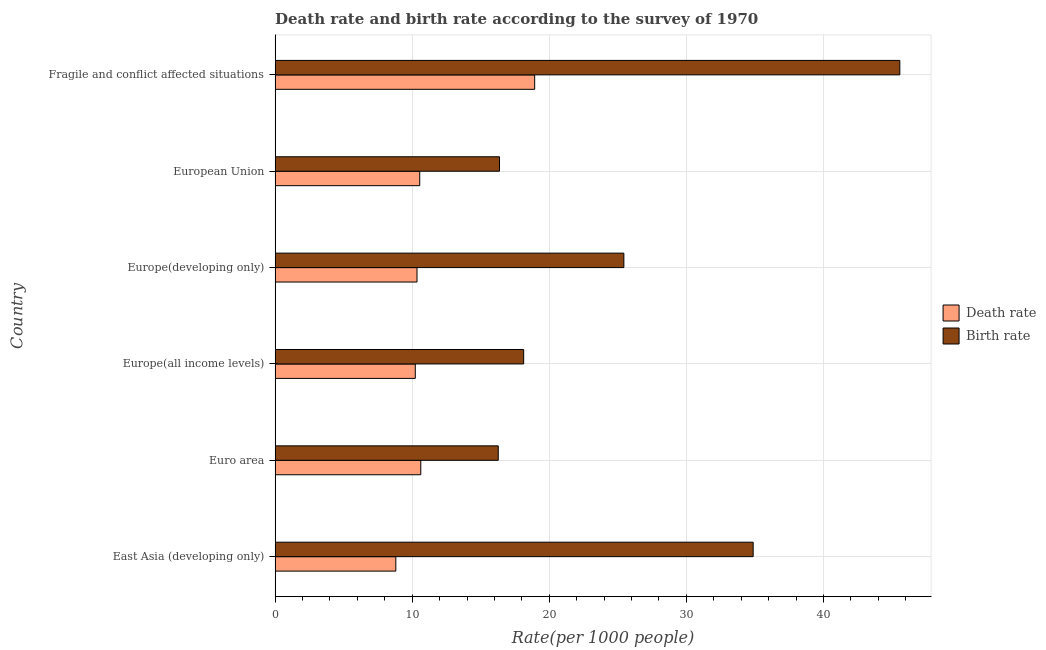How many different coloured bars are there?
Provide a short and direct response. 2. How many groups of bars are there?
Make the answer very short. 6. Are the number of bars per tick equal to the number of legend labels?
Your answer should be very brief. Yes. How many bars are there on the 5th tick from the top?
Keep it short and to the point. 2. How many bars are there on the 2nd tick from the bottom?
Your answer should be compact. 2. What is the label of the 6th group of bars from the top?
Give a very brief answer. East Asia (developing only). What is the death rate in Fragile and conflict affected situations?
Keep it short and to the point. 18.93. Across all countries, what is the maximum death rate?
Make the answer very short. 18.93. Across all countries, what is the minimum death rate?
Your answer should be very brief. 8.81. In which country was the death rate maximum?
Ensure brevity in your answer.  Fragile and conflict affected situations. In which country was the death rate minimum?
Your answer should be very brief. East Asia (developing only). What is the total death rate in the graph?
Your answer should be compact. 69.5. What is the difference between the birth rate in East Asia (developing only) and that in Fragile and conflict affected situations?
Offer a very short reply. -10.7. What is the difference between the death rate in Euro area and the birth rate in Fragile and conflict affected situations?
Keep it short and to the point. -34.94. What is the average birth rate per country?
Give a very brief answer. 26.11. What is the difference between the birth rate and death rate in European Union?
Offer a terse response. 5.82. In how many countries, is the birth rate greater than 2 ?
Offer a terse response. 6. What is the ratio of the death rate in Euro area to that in Fragile and conflict affected situations?
Make the answer very short. 0.56. What is the difference between the highest and the second highest death rate?
Keep it short and to the point. 8.31. What is the difference between the highest and the lowest death rate?
Ensure brevity in your answer.  10.13. What does the 1st bar from the top in Euro area represents?
Your response must be concise. Birth rate. What does the 2nd bar from the bottom in European Union represents?
Give a very brief answer. Birth rate. How many bars are there?
Your response must be concise. 12. Are all the bars in the graph horizontal?
Provide a short and direct response. Yes. What is the difference between two consecutive major ticks on the X-axis?
Ensure brevity in your answer.  10. Are the values on the major ticks of X-axis written in scientific E-notation?
Your answer should be very brief. No. Where does the legend appear in the graph?
Provide a short and direct response. Center right. How are the legend labels stacked?
Ensure brevity in your answer.  Vertical. What is the title of the graph?
Make the answer very short. Death rate and birth rate according to the survey of 1970. What is the label or title of the X-axis?
Give a very brief answer. Rate(per 1000 people). What is the Rate(per 1000 people) in Death rate in East Asia (developing only)?
Your answer should be very brief. 8.81. What is the Rate(per 1000 people) in Birth rate in East Asia (developing only)?
Your response must be concise. 34.87. What is the Rate(per 1000 people) in Death rate in Euro area?
Your answer should be very brief. 10.63. What is the Rate(per 1000 people) in Birth rate in Euro area?
Ensure brevity in your answer.  16.28. What is the Rate(per 1000 people) of Death rate in Europe(all income levels)?
Offer a very short reply. 10.23. What is the Rate(per 1000 people) of Birth rate in Europe(all income levels)?
Your response must be concise. 18.13. What is the Rate(per 1000 people) in Death rate in Europe(developing only)?
Your response must be concise. 10.35. What is the Rate(per 1000 people) of Birth rate in Europe(developing only)?
Give a very brief answer. 25.44. What is the Rate(per 1000 people) in Death rate in European Union?
Offer a very short reply. 10.55. What is the Rate(per 1000 people) in Birth rate in European Union?
Provide a short and direct response. 16.37. What is the Rate(per 1000 people) in Death rate in Fragile and conflict affected situations?
Keep it short and to the point. 18.93. What is the Rate(per 1000 people) of Birth rate in Fragile and conflict affected situations?
Keep it short and to the point. 45.57. Across all countries, what is the maximum Rate(per 1000 people) of Death rate?
Provide a short and direct response. 18.93. Across all countries, what is the maximum Rate(per 1000 people) of Birth rate?
Give a very brief answer. 45.57. Across all countries, what is the minimum Rate(per 1000 people) of Death rate?
Offer a terse response. 8.81. Across all countries, what is the minimum Rate(per 1000 people) in Birth rate?
Your answer should be compact. 16.28. What is the total Rate(per 1000 people) in Death rate in the graph?
Keep it short and to the point. 69.5. What is the total Rate(per 1000 people) of Birth rate in the graph?
Ensure brevity in your answer.  156.66. What is the difference between the Rate(per 1000 people) in Death rate in East Asia (developing only) and that in Euro area?
Provide a short and direct response. -1.82. What is the difference between the Rate(per 1000 people) in Birth rate in East Asia (developing only) and that in Euro area?
Provide a short and direct response. 18.59. What is the difference between the Rate(per 1000 people) in Death rate in East Asia (developing only) and that in Europe(all income levels)?
Keep it short and to the point. -1.42. What is the difference between the Rate(per 1000 people) in Birth rate in East Asia (developing only) and that in Europe(all income levels)?
Ensure brevity in your answer.  16.74. What is the difference between the Rate(per 1000 people) of Death rate in East Asia (developing only) and that in Europe(developing only)?
Keep it short and to the point. -1.55. What is the difference between the Rate(per 1000 people) of Birth rate in East Asia (developing only) and that in Europe(developing only)?
Keep it short and to the point. 9.43. What is the difference between the Rate(per 1000 people) in Death rate in East Asia (developing only) and that in European Union?
Your response must be concise. -1.74. What is the difference between the Rate(per 1000 people) in Birth rate in East Asia (developing only) and that in European Union?
Your answer should be very brief. 18.5. What is the difference between the Rate(per 1000 people) in Death rate in East Asia (developing only) and that in Fragile and conflict affected situations?
Give a very brief answer. -10.13. What is the difference between the Rate(per 1000 people) of Birth rate in East Asia (developing only) and that in Fragile and conflict affected situations?
Provide a succinct answer. -10.7. What is the difference between the Rate(per 1000 people) of Death rate in Euro area and that in Europe(all income levels)?
Provide a succinct answer. 0.4. What is the difference between the Rate(per 1000 people) of Birth rate in Euro area and that in Europe(all income levels)?
Provide a short and direct response. -1.85. What is the difference between the Rate(per 1000 people) of Death rate in Euro area and that in Europe(developing only)?
Your answer should be very brief. 0.28. What is the difference between the Rate(per 1000 people) of Birth rate in Euro area and that in Europe(developing only)?
Make the answer very short. -9.16. What is the difference between the Rate(per 1000 people) of Death rate in Euro area and that in European Union?
Make the answer very short. 0.08. What is the difference between the Rate(per 1000 people) in Birth rate in Euro area and that in European Union?
Offer a terse response. -0.09. What is the difference between the Rate(per 1000 people) of Death rate in Euro area and that in Fragile and conflict affected situations?
Keep it short and to the point. -8.31. What is the difference between the Rate(per 1000 people) in Birth rate in Euro area and that in Fragile and conflict affected situations?
Make the answer very short. -29.29. What is the difference between the Rate(per 1000 people) in Death rate in Europe(all income levels) and that in Europe(developing only)?
Offer a very short reply. -0.12. What is the difference between the Rate(per 1000 people) in Birth rate in Europe(all income levels) and that in Europe(developing only)?
Ensure brevity in your answer.  -7.31. What is the difference between the Rate(per 1000 people) in Death rate in Europe(all income levels) and that in European Union?
Give a very brief answer. -0.32. What is the difference between the Rate(per 1000 people) in Birth rate in Europe(all income levels) and that in European Union?
Provide a short and direct response. 1.76. What is the difference between the Rate(per 1000 people) in Death rate in Europe(all income levels) and that in Fragile and conflict affected situations?
Provide a short and direct response. -8.71. What is the difference between the Rate(per 1000 people) of Birth rate in Europe(all income levels) and that in Fragile and conflict affected situations?
Offer a terse response. -27.44. What is the difference between the Rate(per 1000 people) of Death rate in Europe(developing only) and that in European Union?
Provide a short and direct response. -0.2. What is the difference between the Rate(per 1000 people) in Birth rate in Europe(developing only) and that in European Union?
Give a very brief answer. 9.07. What is the difference between the Rate(per 1000 people) of Death rate in Europe(developing only) and that in Fragile and conflict affected situations?
Provide a short and direct response. -8.58. What is the difference between the Rate(per 1000 people) in Birth rate in Europe(developing only) and that in Fragile and conflict affected situations?
Make the answer very short. -20.13. What is the difference between the Rate(per 1000 people) in Death rate in European Union and that in Fragile and conflict affected situations?
Your response must be concise. -8.38. What is the difference between the Rate(per 1000 people) of Birth rate in European Union and that in Fragile and conflict affected situations?
Ensure brevity in your answer.  -29.2. What is the difference between the Rate(per 1000 people) in Death rate in East Asia (developing only) and the Rate(per 1000 people) in Birth rate in Euro area?
Provide a succinct answer. -7.47. What is the difference between the Rate(per 1000 people) in Death rate in East Asia (developing only) and the Rate(per 1000 people) in Birth rate in Europe(all income levels)?
Provide a succinct answer. -9.33. What is the difference between the Rate(per 1000 people) of Death rate in East Asia (developing only) and the Rate(per 1000 people) of Birth rate in Europe(developing only)?
Provide a short and direct response. -16.63. What is the difference between the Rate(per 1000 people) of Death rate in East Asia (developing only) and the Rate(per 1000 people) of Birth rate in European Union?
Your answer should be very brief. -7.56. What is the difference between the Rate(per 1000 people) in Death rate in East Asia (developing only) and the Rate(per 1000 people) in Birth rate in Fragile and conflict affected situations?
Provide a short and direct response. -36.76. What is the difference between the Rate(per 1000 people) of Death rate in Euro area and the Rate(per 1000 people) of Birth rate in Europe(all income levels)?
Your answer should be compact. -7.5. What is the difference between the Rate(per 1000 people) of Death rate in Euro area and the Rate(per 1000 people) of Birth rate in Europe(developing only)?
Provide a short and direct response. -14.81. What is the difference between the Rate(per 1000 people) of Death rate in Euro area and the Rate(per 1000 people) of Birth rate in European Union?
Give a very brief answer. -5.74. What is the difference between the Rate(per 1000 people) in Death rate in Euro area and the Rate(per 1000 people) in Birth rate in Fragile and conflict affected situations?
Your answer should be compact. -34.94. What is the difference between the Rate(per 1000 people) in Death rate in Europe(all income levels) and the Rate(per 1000 people) in Birth rate in Europe(developing only)?
Provide a short and direct response. -15.21. What is the difference between the Rate(per 1000 people) in Death rate in Europe(all income levels) and the Rate(per 1000 people) in Birth rate in European Union?
Your answer should be very brief. -6.14. What is the difference between the Rate(per 1000 people) in Death rate in Europe(all income levels) and the Rate(per 1000 people) in Birth rate in Fragile and conflict affected situations?
Ensure brevity in your answer.  -35.34. What is the difference between the Rate(per 1000 people) of Death rate in Europe(developing only) and the Rate(per 1000 people) of Birth rate in European Union?
Offer a terse response. -6.02. What is the difference between the Rate(per 1000 people) in Death rate in Europe(developing only) and the Rate(per 1000 people) in Birth rate in Fragile and conflict affected situations?
Make the answer very short. -35.22. What is the difference between the Rate(per 1000 people) in Death rate in European Union and the Rate(per 1000 people) in Birth rate in Fragile and conflict affected situations?
Offer a terse response. -35.02. What is the average Rate(per 1000 people) of Death rate per country?
Offer a terse response. 11.58. What is the average Rate(per 1000 people) of Birth rate per country?
Give a very brief answer. 26.11. What is the difference between the Rate(per 1000 people) in Death rate and Rate(per 1000 people) in Birth rate in East Asia (developing only)?
Give a very brief answer. -26.07. What is the difference between the Rate(per 1000 people) of Death rate and Rate(per 1000 people) of Birth rate in Euro area?
Provide a succinct answer. -5.65. What is the difference between the Rate(per 1000 people) in Death rate and Rate(per 1000 people) in Birth rate in Europe(all income levels)?
Provide a succinct answer. -7.9. What is the difference between the Rate(per 1000 people) in Death rate and Rate(per 1000 people) in Birth rate in Europe(developing only)?
Ensure brevity in your answer.  -15.09. What is the difference between the Rate(per 1000 people) of Death rate and Rate(per 1000 people) of Birth rate in European Union?
Offer a terse response. -5.82. What is the difference between the Rate(per 1000 people) in Death rate and Rate(per 1000 people) in Birth rate in Fragile and conflict affected situations?
Provide a short and direct response. -26.63. What is the ratio of the Rate(per 1000 people) of Death rate in East Asia (developing only) to that in Euro area?
Keep it short and to the point. 0.83. What is the ratio of the Rate(per 1000 people) of Birth rate in East Asia (developing only) to that in Euro area?
Offer a terse response. 2.14. What is the ratio of the Rate(per 1000 people) of Death rate in East Asia (developing only) to that in Europe(all income levels)?
Make the answer very short. 0.86. What is the ratio of the Rate(per 1000 people) of Birth rate in East Asia (developing only) to that in Europe(all income levels)?
Make the answer very short. 1.92. What is the ratio of the Rate(per 1000 people) in Death rate in East Asia (developing only) to that in Europe(developing only)?
Your answer should be very brief. 0.85. What is the ratio of the Rate(per 1000 people) in Birth rate in East Asia (developing only) to that in Europe(developing only)?
Your answer should be compact. 1.37. What is the ratio of the Rate(per 1000 people) of Death rate in East Asia (developing only) to that in European Union?
Ensure brevity in your answer.  0.83. What is the ratio of the Rate(per 1000 people) in Birth rate in East Asia (developing only) to that in European Union?
Keep it short and to the point. 2.13. What is the ratio of the Rate(per 1000 people) of Death rate in East Asia (developing only) to that in Fragile and conflict affected situations?
Provide a short and direct response. 0.47. What is the ratio of the Rate(per 1000 people) in Birth rate in East Asia (developing only) to that in Fragile and conflict affected situations?
Offer a terse response. 0.77. What is the ratio of the Rate(per 1000 people) of Death rate in Euro area to that in Europe(all income levels)?
Ensure brevity in your answer.  1.04. What is the ratio of the Rate(per 1000 people) of Birth rate in Euro area to that in Europe(all income levels)?
Your response must be concise. 0.9. What is the ratio of the Rate(per 1000 people) of Death rate in Euro area to that in Europe(developing only)?
Offer a very short reply. 1.03. What is the ratio of the Rate(per 1000 people) of Birth rate in Euro area to that in Europe(developing only)?
Your answer should be very brief. 0.64. What is the ratio of the Rate(per 1000 people) in Death rate in Euro area to that in European Union?
Keep it short and to the point. 1.01. What is the ratio of the Rate(per 1000 people) in Birth rate in Euro area to that in European Union?
Your response must be concise. 0.99. What is the ratio of the Rate(per 1000 people) in Death rate in Euro area to that in Fragile and conflict affected situations?
Ensure brevity in your answer.  0.56. What is the ratio of the Rate(per 1000 people) of Birth rate in Euro area to that in Fragile and conflict affected situations?
Make the answer very short. 0.36. What is the ratio of the Rate(per 1000 people) in Death rate in Europe(all income levels) to that in Europe(developing only)?
Give a very brief answer. 0.99. What is the ratio of the Rate(per 1000 people) of Birth rate in Europe(all income levels) to that in Europe(developing only)?
Ensure brevity in your answer.  0.71. What is the ratio of the Rate(per 1000 people) in Death rate in Europe(all income levels) to that in European Union?
Give a very brief answer. 0.97. What is the ratio of the Rate(per 1000 people) of Birth rate in Europe(all income levels) to that in European Union?
Offer a very short reply. 1.11. What is the ratio of the Rate(per 1000 people) of Death rate in Europe(all income levels) to that in Fragile and conflict affected situations?
Your response must be concise. 0.54. What is the ratio of the Rate(per 1000 people) in Birth rate in Europe(all income levels) to that in Fragile and conflict affected situations?
Offer a terse response. 0.4. What is the ratio of the Rate(per 1000 people) in Death rate in Europe(developing only) to that in European Union?
Keep it short and to the point. 0.98. What is the ratio of the Rate(per 1000 people) in Birth rate in Europe(developing only) to that in European Union?
Keep it short and to the point. 1.55. What is the ratio of the Rate(per 1000 people) in Death rate in Europe(developing only) to that in Fragile and conflict affected situations?
Provide a short and direct response. 0.55. What is the ratio of the Rate(per 1000 people) in Birth rate in Europe(developing only) to that in Fragile and conflict affected situations?
Your answer should be very brief. 0.56. What is the ratio of the Rate(per 1000 people) of Death rate in European Union to that in Fragile and conflict affected situations?
Your answer should be compact. 0.56. What is the ratio of the Rate(per 1000 people) of Birth rate in European Union to that in Fragile and conflict affected situations?
Your answer should be compact. 0.36. What is the difference between the highest and the second highest Rate(per 1000 people) in Death rate?
Keep it short and to the point. 8.31. What is the difference between the highest and the second highest Rate(per 1000 people) in Birth rate?
Offer a terse response. 10.7. What is the difference between the highest and the lowest Rate(per 1000 people) in Death rate?
Make the answer very short. 10.13. What is the difference between the highest and the lowest Rate(per 1000 people) in Birth rate?
Provide a succinct answer. 29.29. 